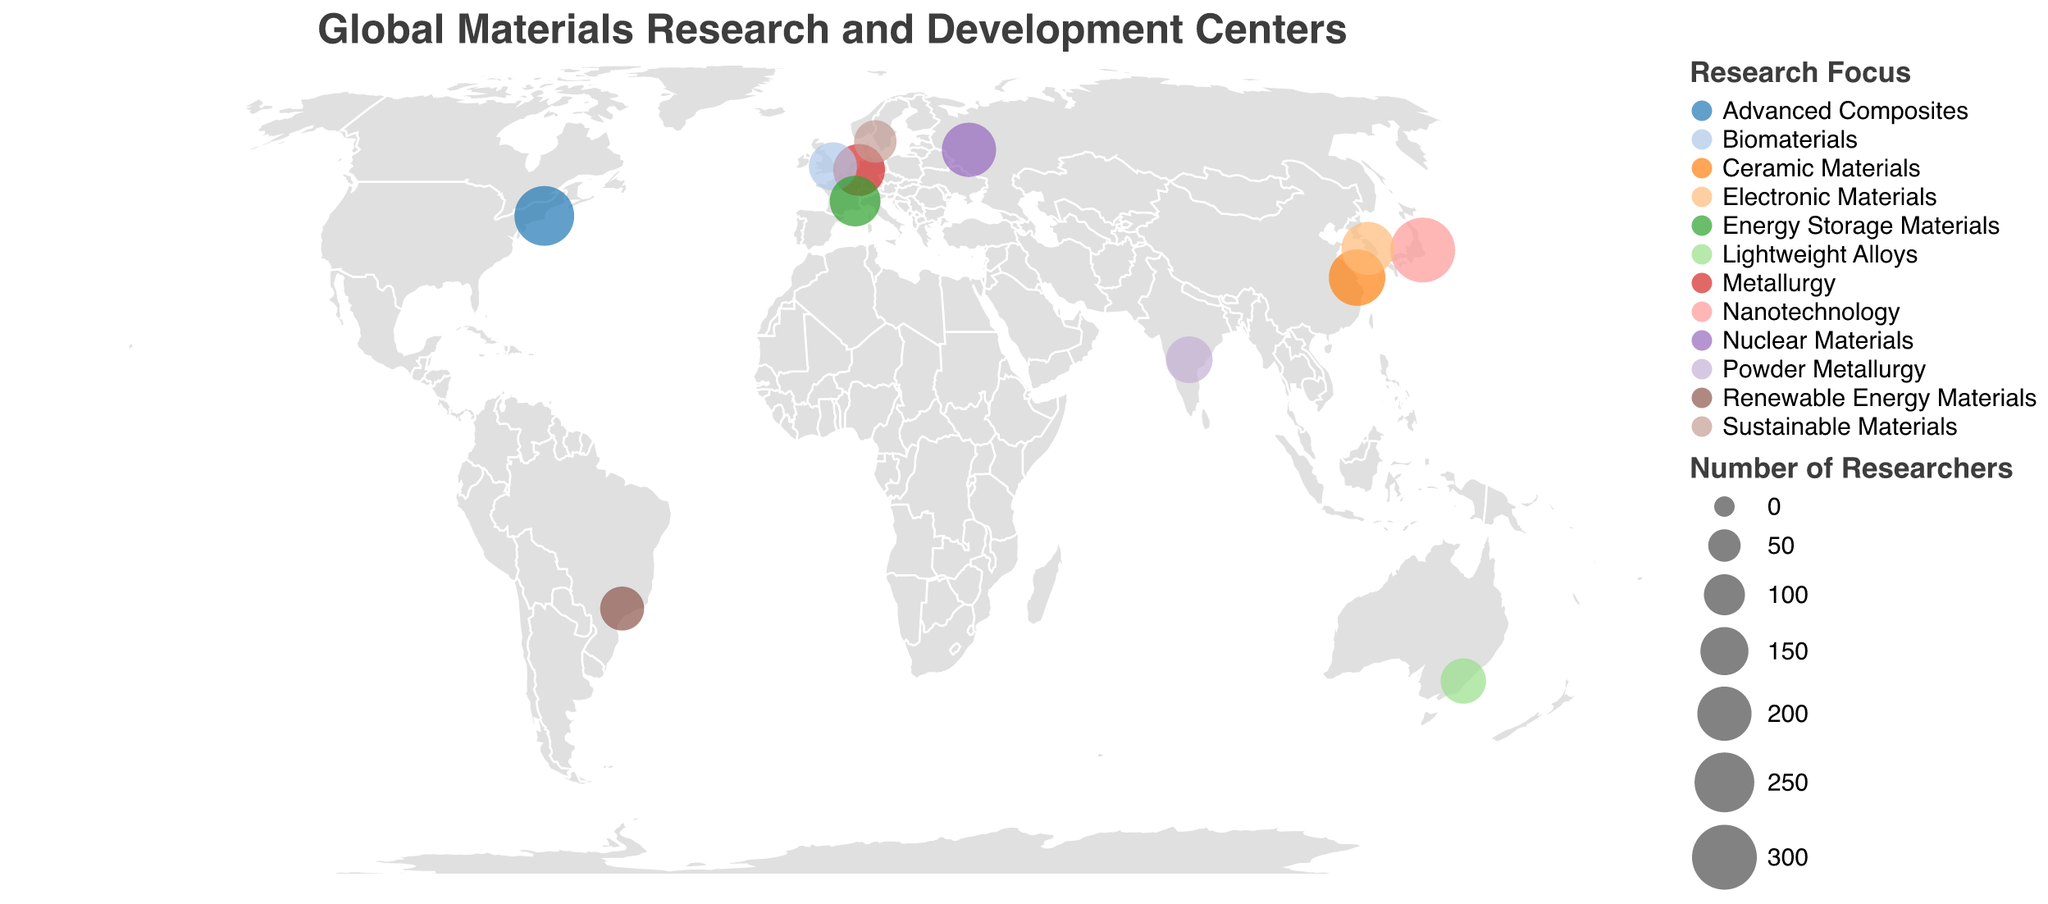What is the title of the figure? The title of the figure is displayed prominently at the top of the plot in a larger font size compared to other text elements. It provides an overview of what the plot represents.
Answer: Global Materials Research and Development Centers Which country has the highest number of researchers? The size of the circle represents the number of researchers, with larger circles indicating more researchers. By comparing the size of the circles, the largest one represents Japan.
Answer: Japan How many research centers focus on nanotechnology? We look at the legend to identify the color associated with 'Nanotechnology' and then count the circles in that color on the map.
Answer: 1 Which country has research focused on 'Advanced Composites'? Based on the legend, we identify the color for 'Advanced Composites' and locate the respective circle on the map.
Answer: USA What is the latitude and longitude of the research center in Brazil? Find the circle representing Brazil on the map and look at the tooltip or data point associated with it.
Answer: -22.8162, -47.0674 How many researchers are there in the materials research center of India? Identify the circle representing India and look at the tooltip or the size encoding information.
Answer: 140 Which research center focuses on 'Nuclear Materials'? Refer to the legend for the color representing 'Nuclear Materials' and find the corresponding circle on the map.
Answer: Kurchatov Institute, Russia Compare the number of researchers between the USA and Germany. Which has more? By looking at the size of the circles for the USA and Germany, the circle for the USA is larger, indicating it has more researchers. USA has 250 researchers, while Germany has 180.
Answer: USA What is the focus area of the research center in Sweden? Locate Sweden on the map by its geographic position and refer to the tooltip or legend for its focus area.
Answer: Sustainable Materials 